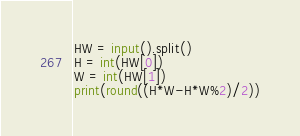Convert code to text. <code><loc_0><loc_0><loc_500><loc_500><_Python_>HW = input().split()
H = int(HW[0])
W = int(HW[1])
print(round((H*W-H*W%2)/2))</code> 